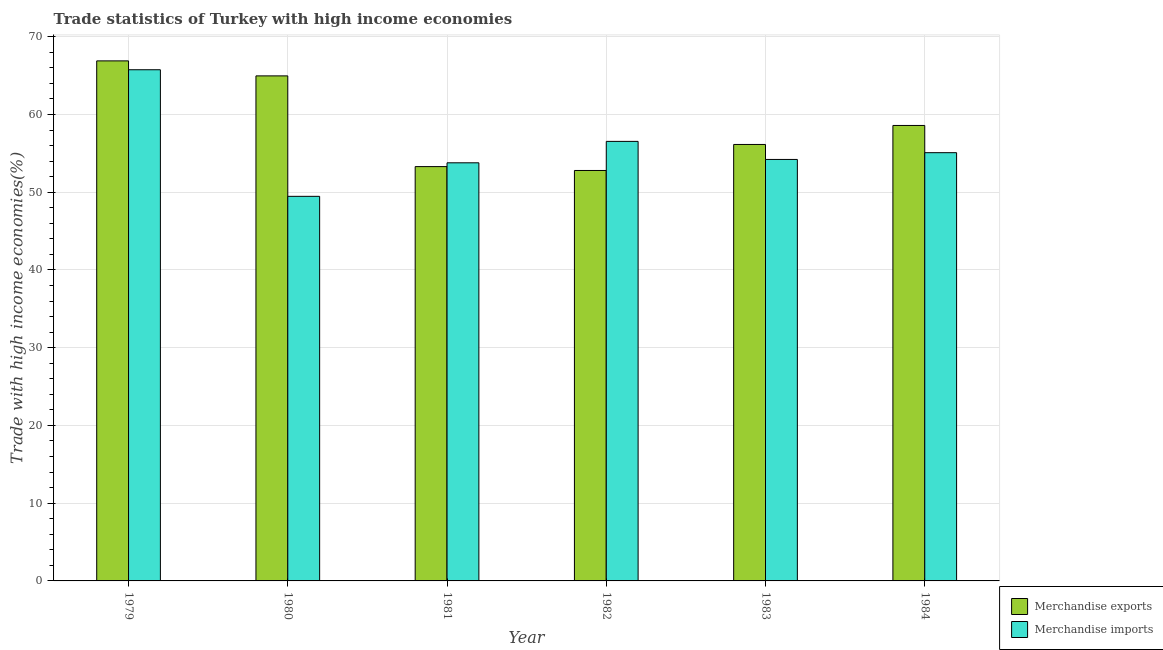How many bars are there on the 3rd tick from the left?
Ensure brevity in your answer.  2. What is the label of the 1st group of bars from the left?
Provide a short and direct response. 1979. What is the merchandise imports in 1981?
Your answer should be very brief. 53.78. Across all years, what is the maximum merchandise exports?
Give a very brief answer. 66.89. Across all years, what is the minimum merchandise imports?
Offer a very short reply. 49.47. In which year was the merchandise exports maximum?
Provide a short and direct response. 1979. In which year was the merchandise exports minimum?
Your response must be concise. 1982. What is the total merchandise imports in the graph?
Offer a terse response. 334.84. What is the difference between the merchandise exports in 1981 and that in 1984?
Your response must be concise. -5.29. What is the difference between the merchandise imports in 1979 and the merchandise exports in 1980?
Provide a succinct answer. 16.28. What is the average merchandise exports per year?
Ensure brevity in your answer.  58.78. In the year 1981, what is the difference between the merchandise exports and merchandise imports?
Ensure brevity in your answer.  0. In how many years, is the merchandise exports greater than 54 %?
Give a very brief answer. 4. What is the ratio of the merchandise exports in 1982 to that in 1983?
Give a very brief answer. 0.94. Is the merchandise imports in 1979 less than that in 1982?
Offer a very short reply. No. Is the difference between the merchandise imports in 1980 and 1983 greater than the difference between the merchandise exports in 1980 and 1983?
Make the answer very short. No. What is the difference between the highest and the second highest merchandise exports?
Keep it short and to the point. 1.93. What is the difference between the highest and the lowest merchandise imports?
Provide a succinct answer. 16.28. In how many years, is the merchandise imports greater than the average merchandise imports taken over all years?
Ensure brevity in your answer.  2. What does the 2nd bar from the left in 1982 represents?
Your answer should be compact. Merchandise imports. What does the 2nd bar from the right in 1979 represents?
Offer a terse response. Merchandise exports. How many bars are there?
Your answer should be compact. 12. Are all the bars in the graph horizontal?
Provide a succinct answer. No. How many years are there in the graph?
Your answer should be compact. 6. Are the values on the major ticks of Y-axis written in scientific E-notation?
Your response must be concise. No. Does the graph contain grids?
Offer a terse response. Yes. How many legend labels are there?
Make the answer very short. 2. How are the legend labels stacked?
Offer a terse response. Vertical. What is the title of the graph?
Ensure brevity in your answer.  Trade statistics of Turkey with high income economies. What is the label or title of the Y-axis?
Make the answer very short. Trade with high income economies(%). What is the Trade with high income economies(%) of Merchandise exports in 1979?
Give a very brief answer. 66.89. What is the Trade with high income economies(%) of Merchandise imports in 1979?
Make the answer very short. 65.75. What is the Trade with high income economies(%) of Merchandise exports in 1980?
Keep it short and to the point. 64.96. What is the Trade with high income economies(%) of Merchandise imports in 1980?
Give a very brief answer. 49.47. What is the Trade with high income economies(%) in Merchandise exports in 1981?
Your answer should be compact. 53.29. What is the Trade with high income economies(%) of Merchandise imports in 1981?
Offer a very short reply. 53.78. What is the Trade with high income economies(%) of Merchandise exports in 1982?
Your answer should be very brief. 52.8. What is the Trade with high income economies(%) in Merchandise imports in 1982?
Offer a terse response. 56.54. What is the Trade with high income economies(%) in Merchandise exports in 1983?
Make the answer very short. 56.14. What is the Trade with high income economies(%) of Merchandise imports in 1983?
Your response must be concise. 54.21. What is the Trade with high income economies(%) of Merchandise exports in 1984?
Make the answer very short. 58.59. What is the Trade with high income economies(%) of Merchandise imports in 1984?
Make the answer very short. 55.08. Across all years, what is the maximum Trade with high income economies(%) in Merchandise exports?
Make the answer very short. 66.89. Across all years, what is the maximum Trade with high income economies(%) in Merchandise imports?
Your response must be concise. 65.75. Across all years, what is the minimum Trade with high income economies(%) of Merchandise exports?
Provide a short and direct response. 52.8. Across all years, what is the minimum Trade with high income economies(%) of Merchandise imports?
Provide a short and direct response. 49.47. What is the total Trade with high income economies(%) in Merchandise exports in the graph?
Offer a terse response. 352.67. What is the total Trade with high income economies(%) in Merchandise imports in the graph?
Keep it short and to the point. 334.84. What is the difference between the Trade with high income economies(%) in Merchandise exports in 1979 and that in 1980?
Make the answer very short. 1.93. What is the difference between the Trade with high income economies(%) in Merchandise imports in 1979 and that in 1980?
Offer a terse response. 16.28. What is the difference between the Trade with high income economies(%) in Merchandise exports in 1979 and that in 1981?
Give a very brief answer. 13.6. What is the difference between the Trade with high income economies(%) of Merchandise imports in 1979 and that in 1981?
Make the answer very short. 11.97. What is the difference between the Trade with high income economies(%) of Merchandise exports in 1979 and that in 1982?
Offer a terse response. 14.1. What is the difference between the Trade with high income economies(%) of Merchandise imports in 1979 and that in 1982?
Keep it short and to the point. 9.21. What is the difference between the Trade with high income economies(%) in Merchandise exports in 1979 and that in 1983?
Keep it short and to the point. 10.75. What is the difference between the Trade with high income economies(%) in Merchandise imports in 1979 and that in 1983?
Your answer should be very brief. 11.54. What is the difference between the Trade with high income economies(%) of Merchandise exports in 1979 and that in 1984?
Ensure brevity in your answer.  8.31. What is the difference between the Trade with high income economies(%) in Merchandise imports in 1979 and that in 1984?
Provide a short and direct response. 10.67. What is the difference between the Trade with high income economies(%) in Merchandise exports in 1980 and that in 1981?
Give a very brief answer. 11.67. What is the difference between the Trade with high income economies(%) of Merchandise imports in 1980 and that in 1981?
Provide a short and direct response. -4.31. What is the difference between the Trade with high income economies(%) of Merchandise exports in 1980 and that in 1982?
Your response must be concise. 12.17. What is the difference between the Trade with high income economies(%) in Merchandise imports in 1980 and that in 1982?
Make the answer very short. -7.07. What is the difference between the Trade with high income economies(%) of Merchandise exports in 1980 and that in 1983?
Offer a very short reply. 8.82. What is the difference between the Trade with high income economies(%) in Merchandise imports in 1980 and that in 1983?
Offer a terse response. -4.74. What is the difference between the Trade with high income economies(%) in Merchandise exports in 1980 and that in 1984?
Keep it short and to the point. 6.38. What is the difference between the Trade with high income economies(%) of Merchandise imports in 1980 and that in 1984?
Offer a terse response. -5.61. What is the difference between the Trade with high income economies(%) in Merchandise exports in 1981 and that in 1982?
Your response must be concise. 0.5. What is the difference between the Trade with high income economies(%) of Merchandise imports in 1981 and that in 1982?
Provide a succinct answer. -2.76. What is the difference between the Trade with high income economies(%) in Merchandise exports in 1981 and that in 1983?
Provide a succinct answer. -2.85. What is the difference between the Trade with high income economies(%) of Merchandise imports in 1981 and that in 1983?
Provide a succinct answer. -0.43. What is the difference between the Trade with high income economies(%) of Merchandise exports in 1981 and that in 1984?
Provide a short and direct response. -5.29. What is the difference between the Trade with high income economies(%) in Merchandise imports in 1981 and that in 1984?
Give a very brief answer. -1.3. What is the difference between the Trade with high income economies(%) in Merchandise exports in 1982 and that in 1983?
Provide a succinct answer. -3.35. What is the difference between the Trade with high income economies(%) in Merchandise imports in 1982 and that in 1983?
Your answer should be very brief. 2.32. What is the difference between the Trade with high income economies(%) of Merchandise exports in 1982 and that in 1984?
Offer a terse response. -5.79. What is the difference between the Trade with high income economies(%) of Merchandise imports in 1982 and that in 1984?
Make the answer very short. 1.45. What is the difference between the Trade with high income economies(%) of Merchandise exports in 1983 and that in 1984?
Provide a short and direct response. -2.44. What is the difference between the Trade with high income economies(%) of Merchandise imports in 1983 and that in 1984?
Make the answer very short. -0.87. What is the difference between the Trade with high income economies(%) of Merchandise exports in 1979 and the Trade with high income economies(%) of Merchandise imports in 1980?
Ensure brevity in your answer.  17.42. What is the difference between the Trade with high income economies(%) of Merchandise exports in 1979 and the Trade with high income economies(%) of Merchandise imports in 1981?
Offer a terse response. 13.11. What is the difference between the Trade with high income economies(%) of Merchandise exports in 1979 and the Trade with high income economies(%) of Merchandise imports in 1982?
Offer a terse response. 10.35. What is the difference between the Trade with high income economies(%) of Merchandise exports in 1979 and the Trade with high income economies(%) of Merchandise imports in 1983?
Your answer should be compact. 12.68. What is the difference between the Trade with high income economies(%) of Merchandise exports in 1979 and the Trade with high income economies(%) of Merchandise imports in 1984?
Your answer should be compact. 11.81. What is the difference between the Trade with high income economies(%) of Merchandise exports in 1980 and the Trade with high income economies(%) of Merchandise imports in 1981?
Offer a terse response. 11.18. What is the difference between the Trade with high income economies(%) of Merchandise exports in 1980 and the Trade with high income economies(%) of Merchandise imports in 1982?
Your response must be concise. 8.42. What is the difference between the Trade with high income economies(%) of Merchandise exports in 1980 and the Trade with high income economies(%) of Merchandise imports in 1983?
Offer a terse response. 10.75. What is the difference between the Trade with high income economies(%) in Merchandise exports in 1980 and the Trade with high income economies(%) in Merchandise imports in 1984?
Make the answer very short. 9.88. What is the difference between the Trade with high income economies(%) in Merchandise exports in 1981 and the Trade with high income economies(%) in Merchandise imports in 1982?
Your answer should be compact. -3.24. What is the difference between the Trade with high income economies(%) in Merchandise exports in 1981 and the Trade with high income economies(%) in Merchandise imports in 1983?
Your answer should be compact. -0.92. What is the difference between the Trade with high income economies(%) in Merchandise exports in 1981 and the Trade with high income economies(%) in Merchandise imports in 1984?
Your answer should be compact. -1.79. What is the difference between the Trade with high income economies(%) of Merchandise exports in 1982 and the Trade with high income economies(%) of Merchandise imports in 1983?
Provide a short and direct response. -1.42. What is the difference between the Trade with high income economies(%) of Merchandise exports in 1982 and the Trade with high income economies(%) of Merchandise imports in 1984?
Give a very brief answer. -2.29. What is the difference between the Trade with high income economies(%) of Merchandise exports in 1983 and the Trade with high income economies(%) of Merchandise imports in 1984?
Provide a succinct answer. 1.06. What is the average Trade with high income economies(%) in Merchandise exports per year?
Your answer should be very brief. 58.78. What is the average Trade with high income economies(%) of Merchandise imports per year?
Your answer should be very brief. 55.81. In the year 1979, what is the difference between the Trade with high income economies(%) of Merchandise exports and Trade with high income economies(%) of Merchandise imports?
Make the answer very short. 1.14. In the year 1980, what is the difference between the Trade with high income economies(%) in Merchandise exports and Trade with high income economies(%) in Merchandise imports?
Provide a succinct answer. 15.49. In the year 1981, what is the difference between the Trade with high income economies(%) in Merchandise exports and Trade with high income economies(%) in Merchandise imports?
Keep it short and to the point. -0.49. In the year 1982, what is the difference between the Trade with high income economies(%) in Merchandise exports and Trade with high income economies(%) in Merchandise imports?
Ensure brevity in your answer.  -3.74. In the year 1983, what is the difference between the Trade with high income economies(%) of Merchandise exports and Trade with high income economies(%) of Merchandise imports?
Provide a short and direct response. 1.93. In the year 1984, what is the difference between the Trade with high income economies(%) in Merchandise exports and Trade with high income economies(%) in Merchandise imports?
Offer a very short reply. 3.5. What is the ratio of the Trade with high income economies(%) in Merchandise exports in 1979 to that in 1980?
Give a very brief answer. 1.03. What is the ratio of the Trade with high income economies(%) of Merchandise imports in 1979 to that in 1980?
Your answer should be compact. 1.33. What is the ratio of the Trade with high income economies(%) in Merchandise exports in 1979 to that in 1981?
Ensure brevity in your answer.  1.26. What is the ratio of the Trade with high income economies(%) in Merchandise imports in 1979 to that in 1981?
Offer a terse response. 1.22. What is the ratio of the Trade with high income economies(%) in Merchandise exports in 1979 to that in 1982?
Provide a short and direct response. 1.27. What is the ratio of the Trade with high income economies(%) in Merchandise imports in 1979 to that in 1982?
Your answer should be very brief. 1.16. What is the ratio of the Trade with high income economies(%) of Merchandise exports in 1979 to that in 1983?
Keep it short and to the point. 1.19. What is the ratio of the Trade with high income economies(%) of Merchandise imports in 1979 to that in 1983?
Your answer should be very brief. 1.21. What is the ratio of the Trade with high income economies(%) of Merchandise exports in 1979 to that in 1984?
Keep it short and to the point. 1.14. What is the ratio of the Trade with high income economies(%) in Merchandise imports in 1979 to that in 1984?
Your response must be concise. 1.19. What is the ratio of the Trade with high income economies(%) of Merchandise exports in 1980 to that in 1981?
Your answer should be very brief. 1.22. What is the ratio of the Trade with high income economies(%) in Merchandise imports in 1980 to that in 1981?
Your response must be concise. 0.92. What is the ratio of the Trade with high income economies(%) in Merchandise exports in 1980 to that in 1982?
Offer a terse response. 1.23. What is the ratio of the Trade with high income economies(%) in Merchandise imports in 1980 to that in 1982?
Offer a terse response. 0.88. What is the ratio of the Trade with high income economies(%) of Merchandise exports in 1980 to that in 1983?
Your response must be concise. 1.16. What is the ratio of the Trade with high income economies(%) in Merchandise imports in 1980 to that in 1983?
Provide a succinct answer. 0.91. What is the ratio of the Trade with high income economies(%) in Merchandise exports in 1980 to that in 1984?
Keep it short and to the point. 1.11. What is the ratio of the Trade with high income economies(%) of Merchandise imports in 1980 to that in 1984?
Your answer should be very brief. 0.9. What is the ratio of the Trade with high income economies(%) in Merchandise exports in 1981 to that in 1982?
Offer a very short reply. 1.01. What is the ratio of the Trade with high income economies(%) in Merchandise imports in 1981 to that in 1982?
Keep it short and to the point. 0.95. What is the ratio of the Trade with high income economies(%) in Merchandise exports in 1981 to that in 1983?
Offer a terse response. 0.95. What is the ratio of the Trade with high income economies(%) of Merchandise imports in 1981 to that in 1983?
Provide a short and direct response. 0.99. What is the ratio of the Trade with high income economies(%) of Merchandise exports in 1981 to that in 1984?
Give a very brief answer. 0.91. What is the ratio of the Trade with high income economies(%) in Merchandise imports in 1981 to that in 1984?
Provide a succinct answer. 0.98. What is the ratio of the Trade with high income economies(%) of Merchandise exports in 1982 to that in 1983?
Make the answer very short. 0.94. What is the ratio of the Trade with high income economies(%) of Merchandise imports in 1982 to that in 1983?
Keep it short and to the point. 1.04. What is the ratio of the Trade with high income economies(%) of Merchandise exports in 1982 to that in 1984?
Provide a short and direct response. 0.9. What is the ratio of the Trade with high income economies(%) of Merchandise imports in 1982 to that in 1984?
Keep it short and to the point. 1.03. What is the ratio of the Trade with high income economies(%) in Merchandise exports in 1983 to that in 1984?
Your answer should be compact. 0.96. What is the ratio of the Trade with high income economies(%) in Merchandise imports in 1983 to that in 1984?
Ensure brevity in your answer.  0.98. What is the difference between the highest and the second highest Trade with high income economies(%) in Merchandise exports?
Your answer should be compact. 1.93. What is the difference between the highest and the second highest Trade with high income economies(%) of Merchandise imports?
Your answer should be compact. 9.21. What is the difference between the highest and the lowest Trade with high income economies(%) of Merchandise exports?
Offer a terse response. 14.1. What is the difference between the highest and the lowest Trade with high income economies(%) of Merchandise imports?
Your answer should be very brief. 16.28. 